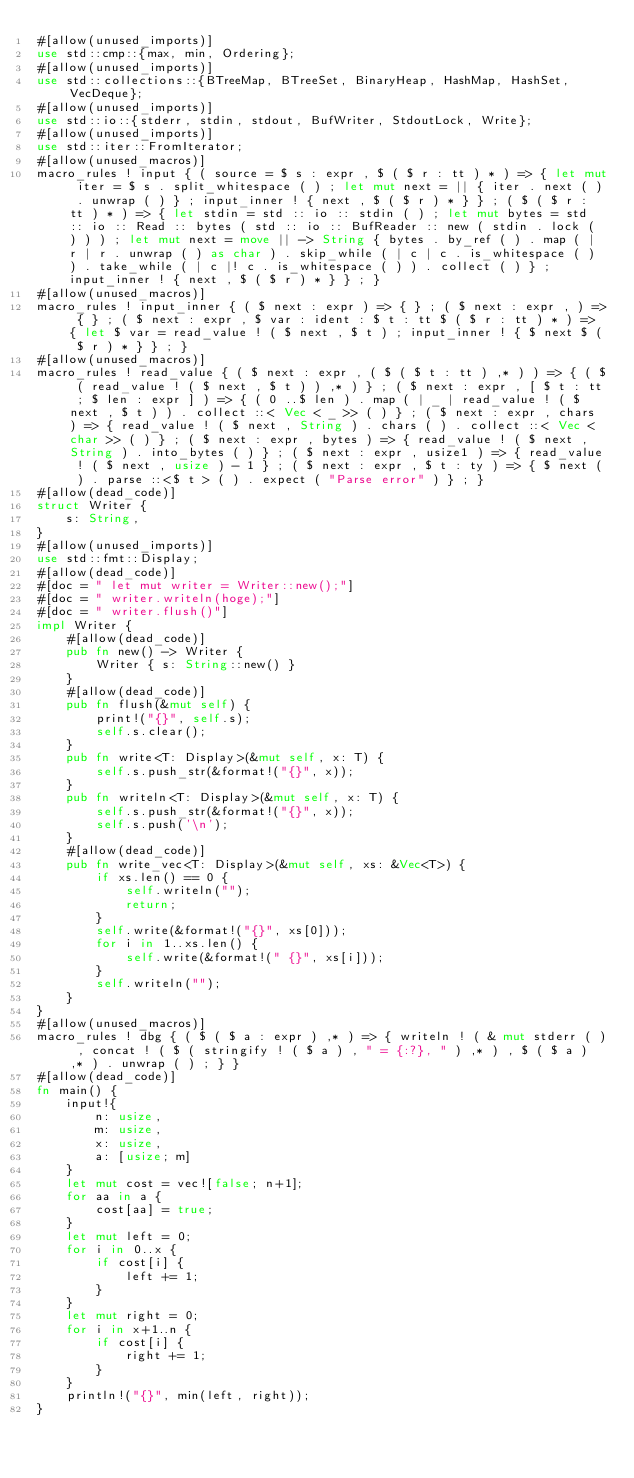Convert code to text. <code><loc_0><loc_0><loc_500><loc_500><_Rust_>#[allow(unused_imports)]
use std::cmp::{max, min, Ordering};
#[allow(unused_imports)]
use std::collections::{BTreeMap, BTreeSet, BinaryHeap, HashMap, HashSet, VecDeque};
#[allow(unused_imports)]
use std::io::{stderr, stdin, stdout, BufWriter, StdoutLock, Write};
#[allow(unused_imports)]
use std::iter::FromIterator;
#[allow(unused_macros)]
macro_rules ! input { ( source = $ s : expr , $ ( $ r : tt ) * ) => { let mut iter = $ s . split_whitespace ( ) ; let mut next = || { iter . next ( ) . unwrap ( ) } ; input_inner ! { next , $ ( $ r ) * } } ; ( $ ( $ r : tt ) * ) => { let stdin = std :: io :: stdin ( ) ; let mut bytes = std :: io :: Read :: bytes ( std :: io :: BufReader :: new ( stdin . lock ( ) ) ) ; let mut next = move || -> String { bytes . by_ref ( ) . map ( | r | r . unwrap ( ) as char ) . skip_while ( | c | c . is_whitespace ( ) ) . take_while ( | c |! c . is_whitespace ( ) ) . collect ( ) } ; input_inner ! { next , $ ( $ r ) * } } ; }
#[allow(unused_macros)]
macro_rules ! input_inner { ( $ next : expr ) => { } ; ( $ next : expr , ) => { } ; ( $ next : expr , $ var : ident : $ t : tt $ ( $ r : tt ) * ) => { let $ var = read_value ! ( $ next , $ t ) ; input_inner ! { $ next $ ( $ r ) * } } ; }
#[allow(unused_macros)]
macro_rules ! read_value { ( $ next : expr , ( $ ( $ t : tt ) ,* ) ) => { ( $ ( read_value ! ( $ next , $ t ) ) ,* ) } ; ( $ next : expr , [ $ t : tt ; $ len : expr ] ) => { ( 0 ..$ len ) . map ( | _ | read_value ! ( $ next , $ t ) ) . collect ::< Vec < _ >> ( ) } ; ( $ next : expr , chars ) => { read_value ! ( $ next , String ) . chars ( ) . collect ::< Vec < char >> ( ) } ; ( $ next : expr , bytes ) => { read_value ! ( $ next , String ) . into_bytes ( ) } ; ( $ next : expr , usize1 ) => { read_value ! ( $ next , usize ) - 1 } ; ( $ next : expr , $ t : ty ) => { $ next ( ) . parse ::<$ t > ( ) . expect ( "Parse error" ) } ; }
#[allow(dead_code)]
struct Writer {
    s: String,
}
#[allow(unused_imports)]
use std::fmt::Display;
#[allow(dead_code)]
#[doc = " let mut writer = Writer::new();"]
#[doc = " writer.writeln(hoge);"]
#[doc = " writer.flush()"]
impl Writer {
    #[allow(dead_code)]
    pub fn new() -> Writer {
        Writer { s: String::new() }
    }
    #[allow(dead_code)]
    pub fn flush(&mut self) {
        print!("{}", self.s);
        self.s.clear();
    }
    pub fn write<T: Display>(&mut self, x: T) {
        self.s.push_str(&format!("{}", x));
    }
    pub fn writeln<T: Display>(&mut self, x: T) {
        self.s.push_str(&format!("{}", x));
        self.s.push('\n');
    }
    #[allow(dead_code)]
    pub fn write_vec<T: Display>(&mut self, xs: &Vec<T>) {
        if xs.len() == 0 {
            self.writeln("");
            return;
        }
        self.write(&format!("{}", xs[0]));
        for i in 1..xs.len() {
            self.write(&format!(" {}", xs[i]));
        }
        self.writeln("");
    }
}
#[allow(unused_macros)]
macro_rules ! dbg { ( $ ( $ a : expr ) ,* ) => { writeln ! ( & mut stderr ( ) , concat ! ( $ ( stringify ! ( $ a ) , " = {:?}, " ) ,* ) , $ ( $ a ) ,* ) . unwrap ( ) ; } }
#[allow(dead_code)]
fn main() {
    input!{
        n: usize,
        m: usize,
        x: usize,
        a: [usize; m]
    }
    let mut cost = vec![false; n+1];
    for aa in a {
        cost[aa] = true;
    }
    let mut left = 0;
    for i in 0..x {
        if cost[i] {
            left += 1;
        }
    }
    let mut right = 0;
    for i in x+1..n {
        if cost[i] {
            right += 1;
        }
    }
    println!("{}", min(left, right));
}</code> 